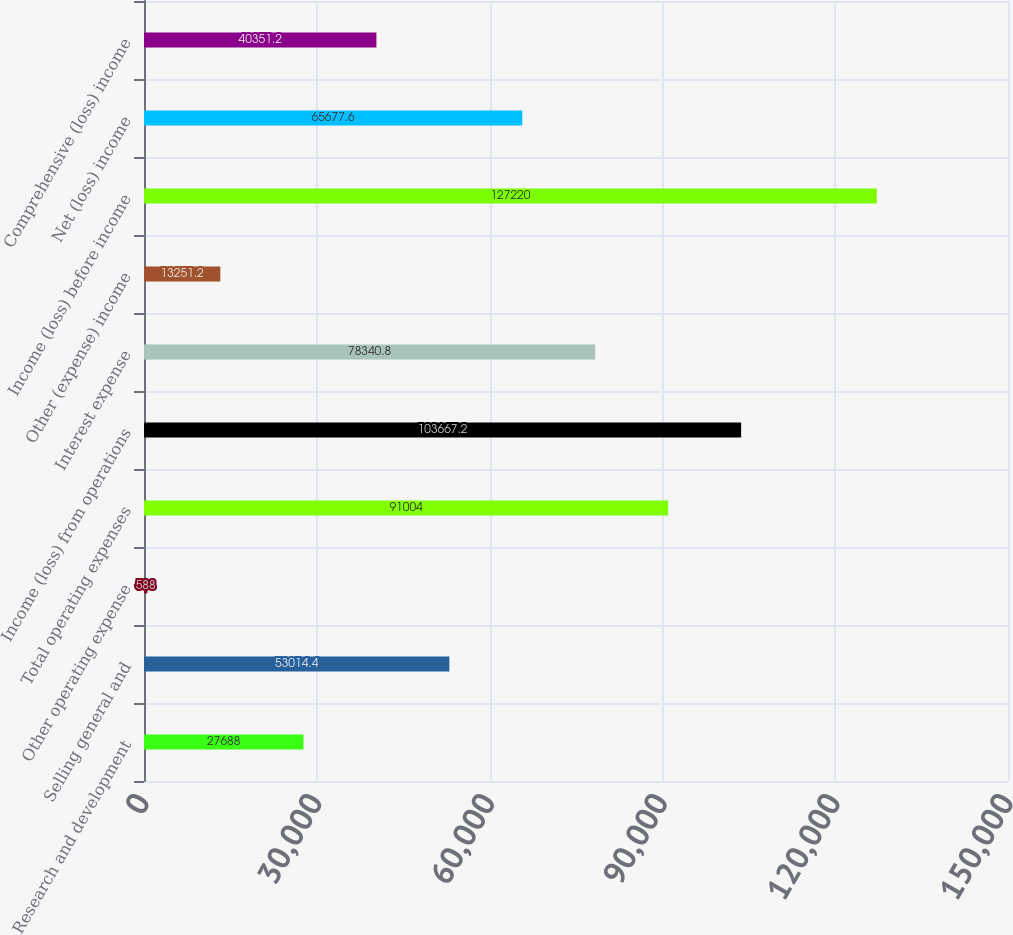<chart> <loc_0><loc_0><loc_500><loc_500><bar_chart><fcel>Research and development<fcel>Selling general and<fcel>Other operating expense<fcel>Total operating expenses<fcel>Income (loss) from operations<fcel>Interest expense<fcel>Other (expense) income<fcel>Income (loss) before income<fcel>Net (loss) income<fcel>Comprehensive (loss) income<nl><fcel>27688<fcel>53014.4<fcel>588<fcel>91004<fcel>103667<fcel>78340.8<fcel>13251.2<fcel>127220<fcel>65677.6<fcel>40351.2<nl></chart> 